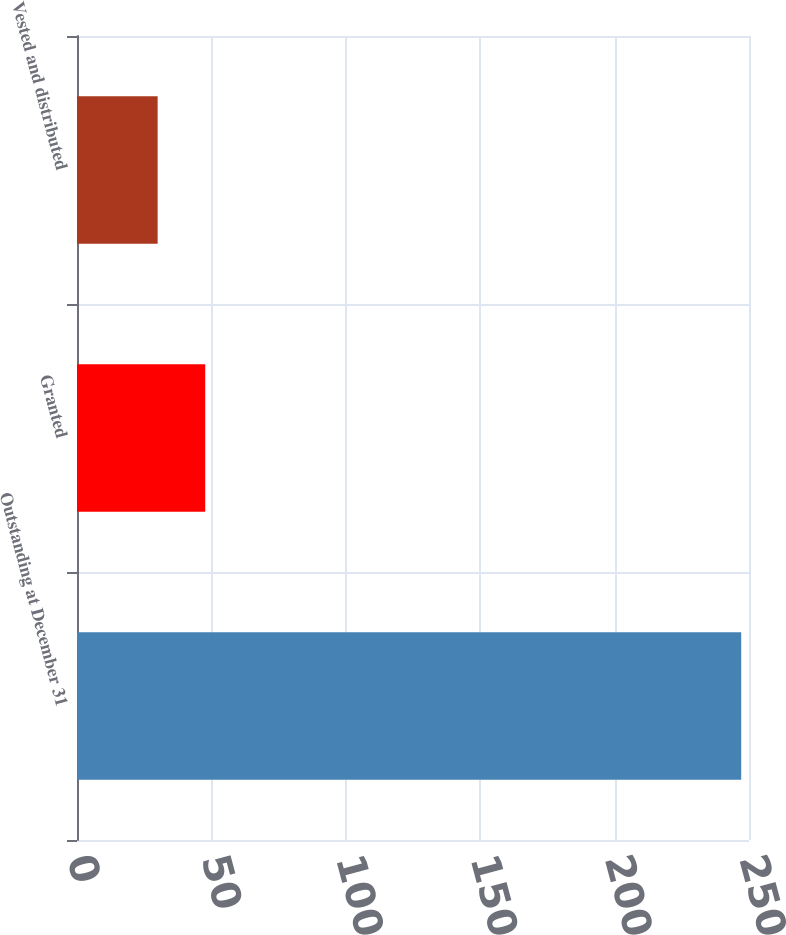Convert chart. <chart><loc_0><loc_0><loc_500><loc_500><bar_chart><fcel>Outstanding at December 31<fcel>Granted<fcel>Vested and distributed<nl><fcel>247.1<fcel>47.7<fcel>30<nl></chart> 